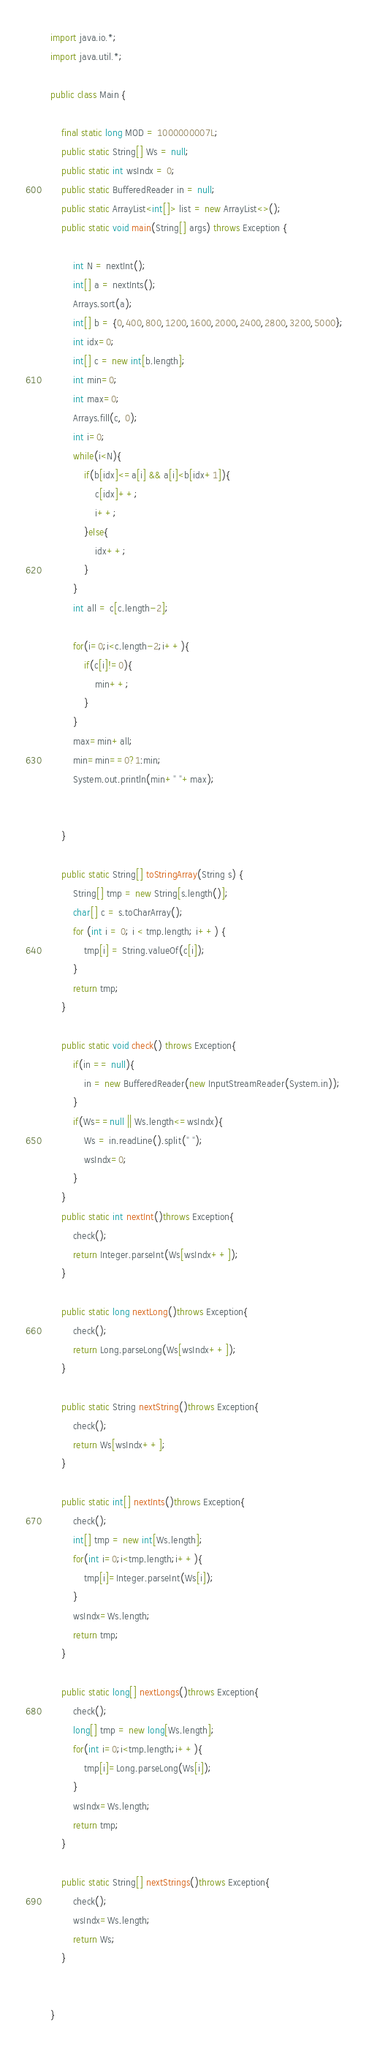Convert code to text. <code><loc_0><loc_0><loc_500><loc_500><_Java_>import java.io.*;
import java.util.*;

public class Main {

	final static long MOD = 1000000007L;
	public static String[] Ws = null;
	public static int wsIndx = 0;
	public static BufferedReader in = null;
	public static ArrayList<int[]> list = new ArrayList<>();
	public static void main(String[] args) throws Exception {

		int N = nextInt();
		int[] a = nextInts();
		Arrays.sort(a);
		int[] b = {0,400,800,1200,1600,2000,2400,2800,3200,5000};
		int idx=0;
		int[] c = new int[b.length];
		int min=0;
		int max=0;
		Arrays.fill(c, 0);
		int i=0;
		while(i<N){
			if(b[idx]<=a[i] && a[i]<b[idx+1]){
				c[idx]++;
				i++;
			}else{
				idx++;
			}
		}
		int all = c[c.length-2];

		for(i=0;i<c.length-2;i++){
			if(c[i]!=0){
				min++;
			}
		}
		max=min+all;
		min=min==0?1:min;
		System.out.println(min+" "+max);


	}

	public static String[] toStringArray(String s) {
		String[] tmp = new String[s.length()];
		char[] c = s.toCharArray();
		for (int i = 0; i < tmp.length; i++) {
			tmp[i] = String.valueOf(c[i]);
		}
		return tmp;
	}

	public static void check() throws Exception{
		if(in == null){
			in = new BufferedReader(new InputStreamReader(System.in));
		}
		if(Ws==null || Ws.length<=wsIndx){
			Ws = in.readLine().split(" ");
			wsIndx=0;
		}
	}
	public static int nextInt()throws Exception{
		check();
		return Integer.parseInt(Ws[wsIndx++]);
	}

	public static long nextLong()throws Exception{
		check();
		return Long.parseLong(Ws[wsIndx++]);
	}

	public static String nextString()throws Exception{
		check();
		return Ws[wsIndx++];
	}

	public static int[] nextInts()throws Exception{
		check();
		int[] tmp = new int[Ws.length];
		for(int i=0;i<tmp.length;i++){
			tmp[i]=Integer.parseInt(Ws[i]);
		}
		wsIndx=Ws.length;
		return tmp;
	}

	public static long[] nextLongs()throws Exception{
		check();
		long[] tmp = new long[Ws.length];
		for(int i=0;i<tmp.length;i++){
			tmp[i]=Long.parseLong(Ws[i]);
		}
		wsIndx=Ws.length;
		return tmp;
	}

	public static String[] nextStrings()throws Exception{
		check();
		wsIndx=Ws.length;
		return Ws;
	}


}
</code> 